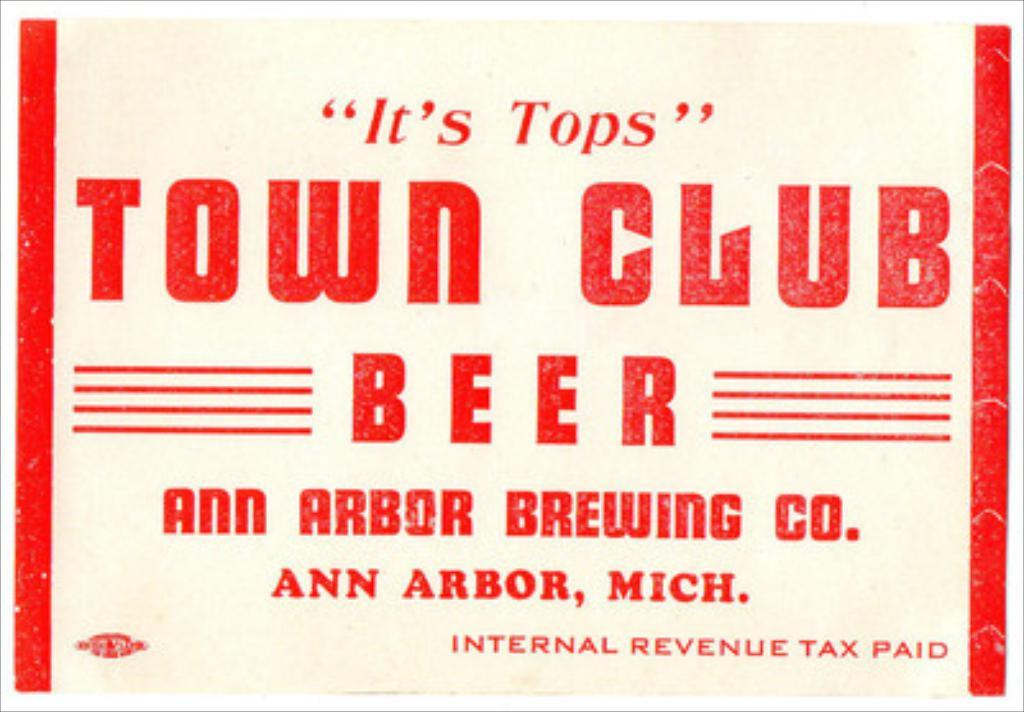Provide a one-sentence caption for the provided image. A old ad for Town Club beer, it is white with red lettering. 